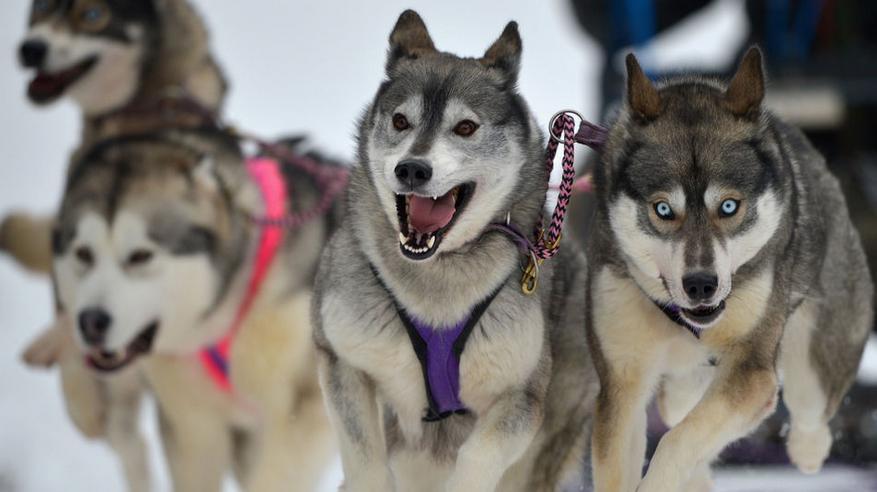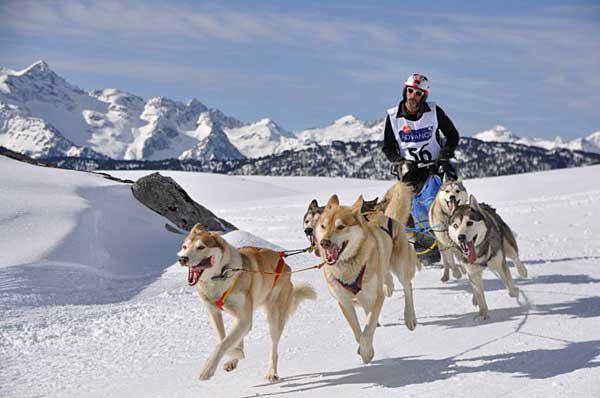The first image is the image on the left, the second image is the image on the right. Analyze the images presented: Is the assertion "Only one rider is visible with the dogs." valid? Answer yes or no. Yes. The first image is the image on the left, the second image is the image on the right. Assess this claim about the two images: "An image shows a sled driver on the right behind a team of dogs facing the camera.". Correct or not? Answer yes or no. Yes. 